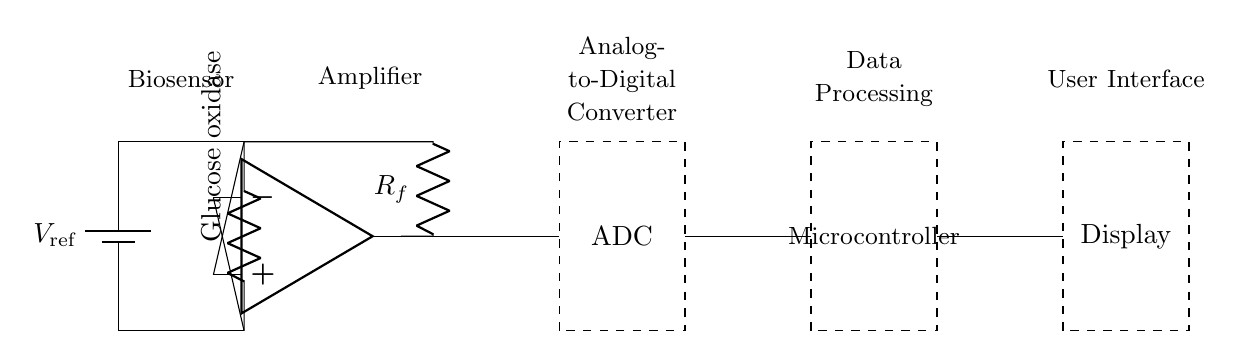What is the first component in the circuit? The first component is a battery labeled as V_ref, which provides the reference voltage for the entire circuit.
Answer: battery What type of sensor is used in this circuit? The sensor used is a glucose oxidase biosensor, which is responsible for detecting glucose levels in the blood.
Answer: glucose oxidase Which component amplifies the signal from the biosensor? The operational amplifier (op amp) is the component that amplifies the signal received from the biosensor.
Answer: op amp What is the purpose of the resistive feedback? The feedback resistor, R_f, is used to control the gain of the op amp and stabilize the output signal before it is sent to the ADC.
Answer: gain control How does the output from the amplifier connect to the ADC? The output of the op amp connects directly to the ADC, enabling the digitization of the analog signal for further processing.
Answer: direct connection What component provides data processing in this circuit? The microcontroller is responsible for processing the digitized data received from the ADC before displaying the results.
Answer: microcontroller 